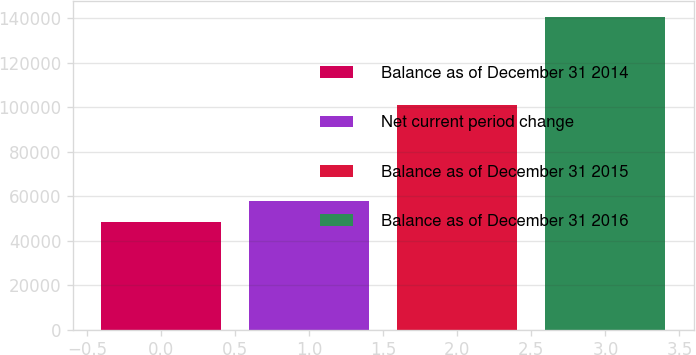Convert chart to OTSL. <chart><loc_0><loc_0><loc_500><loc_500><bar_chart><fcel>Balance as of December 31 2014<fcel>Net current period change<fcel>Balance as of December 31 2015<fcel>Balance as of December 31 2016<nl><fcel>48433<fcel>57651.6<fcel>100964<fcel>140619<nl></chart> 